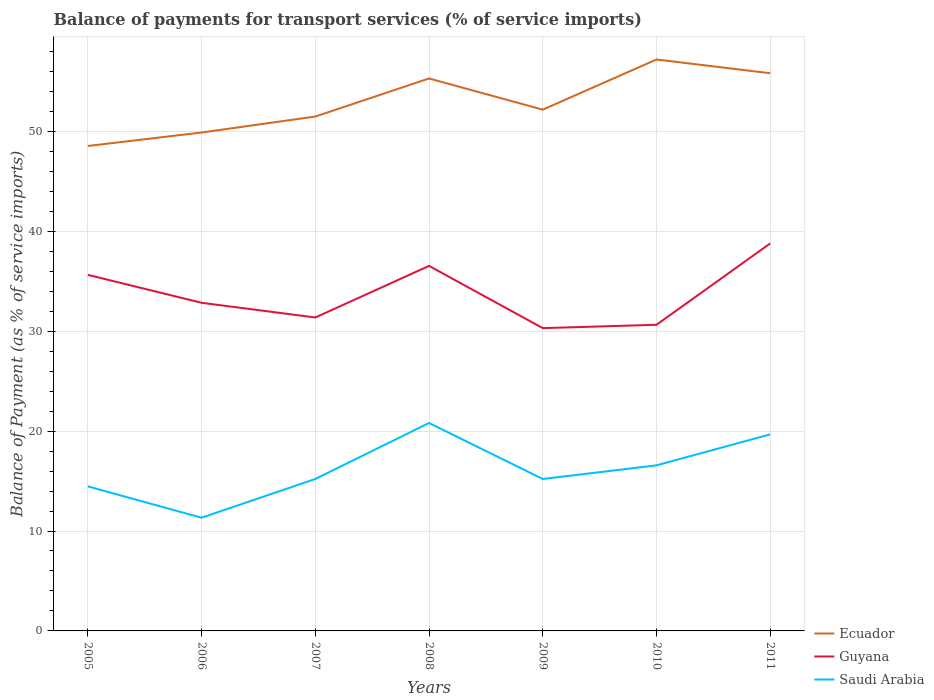How many different coloured lines are there?
Provide a short and direct response. 3. Does the line corresponding to Guyana intersect with the line corresponding to Saudi Arabia?
Your answer should be very brief. No. Is the number of lines equal to the number of legend labels?
Offer a terse response. Yes. Across all years, what is the maximum balance of payments for transport services in Ecuador?
Provide a short and direct response. 48.53. What is the total balance of payments for transport services in Ecuador in the graph?
Your response must be concise. -3.81. What is the difference between the highest and the second highest balance of payments for transport services in Saudi Arabia?
Your response must be concise. 9.48. What is the difference between the highest and the lowest balance of payments for transport services in Guyana?
Your answer should be compact. 3. How many years are there in the graph?
Offer a very short reply. 7. Are the values on the major ticks of Y-axis written in scientific E-notation?
Ensure brevity in your answer.  No. Does the graph contain any zero values?
Make the answer very short. No. Does the graph contain grids?
Ensure brevity in your answer.  Yes. Where does the legend appear in the graph?
Make the answer very short. Bottom right. How many legend labels are there?
Your answer should be very brief. 3. How are the legend labels stacked?
Make the answer very short. Vertical. What is the title of the graph?
Give a very brief answer. Balance of payments for transport services (% of service imports). What is the label or title of the X-axis?
Ensure brevity in your answer.  Years. What is the label or title of the Y-axis?
Provide a succinct answer. Balance of Payment (as % of service imports). What is the Balance of Payment (as % of service imports) of Ecuador in 2005?
Ensure brevity in your answer.  48.53. What is the Balance of Payment (as % of service imports) in Guyana in 2005?
Ensure brevity in your answer.  35.64. What is the Balance of Payment (as % of service imports) of Saudi Arabia in 2005?
Keep it short and to the point. 14.47. What is the Balance of Payment (as % of service imports) in Ecuador in 2006?
Provide a succinct answer. 49.88. What is the Balance of Payment (as % of service imports) of Guyana in 2006?
Offer a terse response. 32.84. What is the Balance of Payment (as % of service imports) in Saudi Arabia in 2006?
Provide a short and direct response. 11.33. What is the Balance of Payment (as % of service imports) of Ecuador in 2007?
Provide a succinct answer. 51.48. What is the Balance of Payment (as % of service imports) in Guyana in 2007?
Your answer should be very brief. 31.37. What is the Balance of Payment (as % of service imports) of Saudi Arabia in 2007?
Your answer should be compact. 15.21. What is the Balance of Payment (as % of service imports) in Ecuador in 2008?
Offer a very short reply. 55.29. What is the Balance of Payment (as % of service imports) of Guyana in 2008?
Your answer should be very brief. 36.53. What is the Balance of Payment (as % of service imports) of Saudi Arabia in 2008?
Give a very brief answer. 20.81. What is the Balance of Payment (as % of service imports) in Ecuador in 2009?
Provide a succinct answer. 52.17. What is the Balance of Payment (as % of service imports) in Guyana in 2009?
Make the answer very short. 30.31. What is the Balance of Payment (as % of service imports) in Saudi Arabia in 2009?
Ensure brevity in your answer.  15.21. What is the Balance of Payment (as % of service imports) in Ecuador in 2010?
Provide a short and direct response. 57.19. What is the Balance of Payment (as % of service imports) of Guyana in 2010?
Your answer should be very brief. 30.64. What is the Balance of Payment (as % of service imports) in Saudi Arabia in 2010?
Provide a short and direct response. 16.57. What is the Balance of Payment (as % of service imports) of Ecuador in 2011?
Your answer should be compact. 55.82. What is the Balance of Payment (as % of service imports) of Guyana in 2011?
Your answer should be compact. 38.79. What is the Balance of Payment (as % of service imports) of Saudi Arabia in 2011?
Offer a terse response. 19.67. Across all years, what is the maximum Balance of Payment (as % of service imports) in Ecuador?
Provide a short and direct response. 57.19. Across all years, what is the maximum Balance of Payment (as % of service imports) in Guyana?
Offer a terse response. 38.79. Across all years, what is the maximum Balance of Payment (as % of service imports) in Saudi Arabia?
Offer a very short reply. 20.81. Across all years, what is the minimum Balance of Payment (as % of service imports) in Ecuador?
Your answer should be very brief. 48.53. Across all years, what is the minimum Balance of Payment (as % of service imports) of Guyana?
Provide a short and direct response. 30.31. Across all years, what is the minimum Balance of Payment (as % of service imports) of Saudi Arabia?
Provide a succinct answer. 11.33. What is the total Balance of Payment (as % of service imports) of Ecuador in the graph?
Ensure brevity in your answer.  370.38. What is the total Balance of Payment (as % of service imports) in Guyana in the graph?
Your answer should be compact. 236.12. What is the total Balance of Payment (as % of service imports) of Saudi Arabia in the graph?
Make the answer very short. 113.27. What is the difference between the Balance of Payment (as % of service imports) in Ecuador in 2005 and that in 2006?
Keep it short and to the point. -1.35. What is the difference between the Balance of Payment (as % of service imports) of Guyana in 2005 and that in 2006?
Provide a short and direct response. 2.8. What is the difference between the Balance of Payment (as % of service imports) in Saudi Arabia in 2005 and that in 2006?
Give a very brief answer. 3.14. What is the difference between the Balance of Payment (as % of service imports) of Ecuador in 2005 and that in 2007?
Provide a succinct answer. -2.95. What is the difference between the Balance of Payment (as % of service imports) in Guyana in 2005 and that in 2007?
Your response must be concise. 4.27. What is the difference between the Balance of Payment (as % of service imports) in Saudi Arabia in 2005 and that in 2007?
Make the answer very short. -0.74. What is the difference between the Balance of Payment (as % of service imports) of Ecuador in 2005 and that in 2008?
Ensure brevity in your answer.  -6.76. What is the difference between the Balance of Payment (as % of service imports) of Guyana in 2005 and that in 2008?
Your response must be concise. -0.9. What is the difference between the Balance of Payment (as % of service imports) in Saudi Arabia in 2005 and that in 2008?
Ensure brevity in your answer.  -6.34. What is the difference between the Balance of Payment (as % of service imports) of Ecuador in 2005 and that in 2009?
Ensure brevity in your answer.  -3.64. What is the difference between the Balance of Payment (as % of service imports) in Guyana in 2005 and that in 2009?
Ensure brevity in your answer.  5.33. What is the difference between the Balance of Payment (as % of service imports) in Saudi Arabia in 2005 and that in 2009?
Offer a terse response. -0.74. What is the difference between the Balance of Payment (as % of service imports) in Ecuador in 2005 and that in 2010?
Keep it short and to the point. -8.66. What is the difference between the Balance of Payment (as % of service imports) in Guyana in 2005 and that in 2010?
Your answer should be compact. 5. What is the difference between the Balance of Payment (as % of service imports) in Saudi Arabia in 2005 and that in 2010?
Provide a short and direct response. -2.11. What is the difference between the Balance of Payment (as % of service imports) of Ecuador in 2005 and that in 2011?
Ensure brevity in your answer.  -7.28. What is the difference between the Balance of Payment (as % of service imports) of Guyana in 2005 and that in 2011?
Ensure brevity in your answer.  -3.15. What is the difference between the Balance of Payment (as % of service imports) of Saudi Arabia in 2005 and that in 2011?
Your response must be concise. -5.2. What is the difference between the Balance of Payment (as % of service imports) of Ecuador in 2006 and that in 2007?
Ensure brevity in your answer.  -1.6. What is the difference between the Balance of Payment (as % of service imports) of Guyana in 2006 and that in 2007?
Your answer should be very brief. 1.47. What is the difference between the Balance of Payment (as % of service imports) in Saudi Arabia in 2006 and that in 2007?
Keep it short and to the point. -3.88. What is the difference between the Balance of Payment (as % of service imports) of Ecuador in 2006 and that in 2008?
Your answer should be very brief. -5.41. What is the difference between the Balance of Payment (as % of service imports) in Guyana in 2006 and that in 2008?
Offer a terse response. -3.69. What is the difference between the Balance of Payment (as % of service imports) in Saudi Arabia in 2006 and that in 2008?
Ensure brevity in your answer.  -9.48. What is the difference between the Balance of Payment (as % of service imports) of Ecuador in 2006 and that in 2009?
Keep it short and to the point. -2.29. What is the difference between the Balance of Payment (as % of service imports) in Guyana in 2006 and that in 2009?
Your response must be concise. 2.54. What is the difference between the Balance of Payment (as % of service imports) of Saudi Arabia in 2006 and that in 2009?
Offer a very short reply. -3.88. What is the difference between the Balance of Payment (as % of service imports) in Ecuador in 2006 and that in 2010?
Provide a succinct answer. -7.31. What is the difference between the Balance of Payment (as % of service imports) of Guyana in 2006 and that in 2010?
Your answer should be very brief. 2.2. What is the difference between the Balance of Payment (as % of service imports) of Saudi Arabia in 2006 and that in 2010?
Give a very brief answer. -5.24. What is the difference between the Balance of Payment (as % of service imports) in Ecuador in 2006 and that in 2011?
Keep it short and to the point. -5.93. What is the difference between the Balance of Payment (as % of service imports) in Guyana in 2006 and that in 2011?
Offer a very short reply. -5.95. What is the difference between the Balance of Payment (as % of service imports) of Saudi Arabia in 2006 and that in 2011?
Offer a very short reply. -8.34. What is the difference between the Balance of Payment (as % of service imports) in Ecuador in 2007 and that in 2008?
Provide a short and direct response. -3.81. What is the difference between the Balance of Payment (as % of service imports) of Guyana in 2007 and that in 2008?
Provide a short and direct response. -5.16. What is the difference between the Balance of Payment (as % of service imports) in Saudi Arabia in 2007 and that in 2008?
Your answer should be compact. -5.6. What is the difference between the Balance of Payment (as % of service imports) of Ecuador in 2007 and that in 2009?
Your response must be concise. -0.69. What is the difference between the Balance of Payment (as % of service imports) in Guyana in 2007 and that in 2009?
Your response must be concise. 1.07. What is the difference between the Balance of Payment (as % of service imports) in Saudi Arabia in 2007 and that in 2009?
Your response must be concise. 0. What is the difference between the Balance of Payment (as % of service imports) of Ecuador in 2007 and that in 2010?
Keep it short and to the point. -5.71. What is the difference between the Balance of Payment (as % of service imports) in Guyana in 2007 and that in 2010?
Your response must be concise. 0.73. What is the difference between the Balance of Payment (as % of service imports) of Saudi Arabia in 2007 and that in 2010?
Your response must be concise. -1.37. What is the difference between the Balance of Payment (as % of service imports) in Ecuador in 2007 and that in 2011?
Provide a short and direct response. -4.33. What is the difference between the Balance of Payment (as % of service imports) in Guyana in 2007 and that in 2011?
Offer a terse response. -7.42. What is the difference between the Balance of Payment (as % of service imports) in Saudi Arabia in 2007 and that in 2011?
Provide a short and direct response. -4.46. What is the difference between the Balance of Payment (as % of service imports) in Ecuador in 2008 and that in 2009?
Your answer should be very brief. 3.12. What is the difference between the Balance of Payment (as % of service imports) in Guyana in 2008 and that in 2009?
Offer a terse response. 6.23. What is the difference between the Balance of Payment (as % of service imports) in Saudi Arabia in 2008 and that in 2009?
Provide a short and direct response. 5.6. What is the difference between the Balance of Payment (as % of service imports) in Ecuador in 2008 and that in 2010?
Your answer should be compact. -1.9. What is the difference between the Balance of Payment (as % of service imports) of Guyana in 2008 and that in 2010?
Offer a terse response. 5.89. What is the difference between the Balance of Payment (as % of service imports) of Saudi Arabia in 2008 and that in 2010?
Your response must be concise. 4.24. What is the difference between the Balance of Payment (as % of service imports) in Ecuador in 2008 and that in 2011?
Provide a succinct answer. -0.52. What is the difference between the Balance of Payment (as % of service imports) in Guyana in 2008 and that in 2011?
Keep it short and to the point. -2.25. What is the difference between the Balance of Payment (as % of service imports) in Saudi Arabia in 2008 and that in 2011?
Ensure brevity in your answer.  1.14. What is the difference between the Balance of Payment (as % of service imports) in Ecuador in 2009 and that in 2010?
Your answer should be very brief. -5.02. What is the difference between the Balance of Payment (as % of service imports) of Guyana in 2009 and that in 2010?
Provide a succinct answer. -0.33. What is the difference between the Balance of Payment (as % of service imports) in Saudi Arabia in 2009 and that in 2010?
Your response must be concise. -1.37. What is the difference between the Balance of Payment (as % of service imports) of Ecuador in 2009 and that in 2011?
Your response must be concise. -3.64. What is the difference between the Balance of Payment (as % of service imports) in Guyana in 2009 and that in 2011?
Make the answer very short. -8.48. What is the difference between the Balance of Payment (as % of service imports) in Saudi Arabia in 2009 and that in 2011?
Make the answer very short. -4.47. What is the difference between the Balance of Payment (as % of service imports) of Ecuador in 2010 and that in 2011?
Provide a succinct answer. 1.38. What is the difference between the Balance of Payment (as % of service imports) of Guyana in 2010 and that in 2011?
Keep it short and to the point. -8.15. What is the difference between the Balance of Payment (as % of service imports) in Saudi Arabia in 2010 and that in 2011?
Give a very brief answer. -3.1. What is the difference between the Balance of Payment (as % of service imports) in Ecuador in 2005 and the Balance of Payment (as % of service imports) in Guyana in 2006?
Give a very brief answer. 15.69. What is the difference between the Balance of Payment (as % of service imports) of Ecuador in 2005 and the Balance of Payment (as % of service imports) of Saudi Arabia in 2006?
Provide a short and direct response. 37.21. What is the difference between the Balance of Payment (as % of service imports) of Guyana in 2005 and the Balance of Payment (as % of service imports) of Saudi Arabia in 2006?
Your response must be concise. 24.31. What is the difference between the Balance of Payment (as % of service imports) in Ecuador in 2005 and the Balance of Payment (as % of service imports) in Guyana in 2007?
Ensure brevity in your answer.  17.16. What is the difference between the Balance of Payment (as % of service imports) of Ecuador in 2005 and the Balance of Payment (as % of service imports) of Saudi Arabia in 2007?
Offer a very short reply. 33.33. What is the difference between the Balance of Payment (as % of service imports) in Guyana in 2005 and the Balance of Payment (as % of service imports) in Saudi Arabia in 2007?
Your response must be concise. 20.43. What is the difference between the Balance of Payment (as % of service imports) of Ecuador in 2005 and the Balance of Payment (as % of service imports) of Guyana in 2008?
Your answer should be very brief. 12. What is the difference between the Balance of Payment (as % of service imports) in Ecuador in 2005 and the Balance of Payment (as % of service imports) in Saudi Arabia in 2008?
Provide a succinct answer. 27.72. What is the difference between the Balance of Payment (as % of service imports) of Guyana in 2005 and the Balance of Payment (as % of service imports) of Saudi Arabia in 2008?
Make the answer very short. 14.83. What is the difference between the Balance of Payment (as % of service imports) in Ecuador in 2005 and the Balance of Payment (as % of service imports) in Guyana in 2009?
Your response must be concise. 18.23. What is the difference between the Balance of Payment (as % of service imports) of Ecuador in 2005 and the Balance of Payment (as % of service imports) of Saudi Arabia in 2009?
Ensure brevity in your answer.  33.33. What is the difference between the Balance of Payment (as % of service imports) in Guyana in 2005 and the Balance of Payment (as % of service imports) in Saudi Arabia in 2009?
Give a very brief answer. 20.43. What is the difference between the Balance of Payment (as % of service imports) in Ecuador in 2005 and the Balance of Payment (as % of service imports) in Guyana in 2010?
Keep it short and to the point. 17.89. What is the difference between the Balance of Payment (as % of service imports) of Ecuador in 2005 and the Balance of Payment (as % of service imports) of Saudi Arabia in 2010?
Offer a very short reply. 31.96. What is the difference between the Balance of Payment (as % of service imports) in Guyana in 2005 and the Balance of Payment (as % of service imports) in Saudi Arabia in 2010?
Offer a very short reply. 19.06. What is the difference between the Balance of Payment (as % of service imports) in Ecuador in 2005 and the Balance of Payment (as % of service imports) in Guyana in 2011?
Give a very brief answer. 9.75. What is the difference between the Balance of Payment (as % of service imports) of Ecuador in 2005 and the Balance of Payment (as % of service imports) of Saudi Arabia in 2011?
Offer a terse response. 28.86. What is the difference between the Balance of Payment (as % of service imports) of Guyana in 2005 and the Balance of Payment (as % of service imports) of Saudi Arabia in 2011?
Provide a succinct answer. 15.97. What is the difference between the Balance of Payment (as % of service imports) in Ecuador in 2006 and the Balance of Payment (as % of service imports) in Guyana in 2007?
Make the answer very short. 18.51. What is the difference between the Balance of Payment (as % of service imports) of Ecuador in 2006 and the Balance of Payment (as % of service imports) of Saudi Arabia in 2007?
Offer a terse response. 34.68. What is the difference between the Balance of Payment (as % of service imports) in Guyana in 2006 and the Balance of Payment (as % of service imports) in Saudi Arabia in 2007?
Offer a very short reply. 17.63. What is the difference between the Balance of Payment (as % of service imports) of Ecuador in 2006 and the Balance of Payment (as % of service imports) of Guyana in 2008?
Your response must be concise. 13.35. What is the difference between the Balance of Payment (as % of service imports) in Ecuador in 2006 and the Balance of Payment (as % of service imports) in Saudi Arabia in 2008?
Offer a terse response. 29.07. What is the difference between the Balance of Payment (as % of service imports) of Guyana in 2006 and the Balance of Payment (as % of service imports) of Saudi Arabia in 2008?
Ensure brevity in your answer.  12.03. What is the difference between the Balance of Payment (as % of service imports) in Ecuador in 2006 and the Balance of Payment (as % of service imports) in Guyana in 2009?
Provide a short and direct response. 19.58. What is the difference between the Balance of Payment (as % of service imports) in Ecuador in 2006 and the Balance of Payment (as % of service imports) in Saudi Arabia in 2009?
Ensure brevity in your answer.  34.68. What is the difference between the Balance of Payment (as % of service imports) in Guyana in 2006 and the Balance of Payment (as % of service imports) in Saudi Arabia in 2009?
Give a very brief answer. 17.64. What is the difference between the Balance of Payment (as % of service imports) in Ecuador in 2006 and the Balance of Payment (as % of service imports) in Guyana in 2010?
Your answer should be compact. 19.24. What is the difference between the Balance of Payment (as % of service imports) in Ecuador in 2006 and the Balance of Payment (as % of service imports) in Saudi Arabia in 2010?
Your answer should be very brief. 33.31. What is the difference between the Balance of Payment (as % of service imports) in Guyana in 2006 and the Balance of Payment (as % of service imports) in Saudi Arabia in 2010?
Offer a terse response. 16.27. What is the difference between the Balance of Payment (as % of service imports) in Ecuador in 2006 and the Balance of Payment (as % of service imports) in Guyana in 2011?
Ensure brevity in your answer.  11.1. What is the difference between the Balance of Payment (as % of service imports) of Ecuador in 2006 and the Balance of Payment (as % of service imports) of Saudi Arabia in 2011?
Ensure brevity in your answer.  30.21. What is the difference between the Balance of Payment (as % of service imports) in Guyana in 2006 and the Balance of Payment (as % of service imports) in Saudi Arabia in 2011?
Offer a very short reply. 13.17. What is the difference between the Balance of Payment (as % of service imports) in Ecuador in 2007 and the Balance of Payment (as % of service imports) in Guyana in 2008?
Your answer should be very brief. 14.95. What is the difference between the Balance of Payment (as % of service imports) of Ecuador in 2007 and the Balance of Payment (as % of service imports) of Saudi Arabia in 2008?
Provide a short and direct response. 30.67. What is the difference between the Balance of Payment (as % of service imports) of Guyana in 2007 and the Balance of Payment (as % of service imports) of Saudi Arabia in 2008?
Your response must be concise. 10.56. What is the difference between the Balance of Payment (as % of service imports) in Ecuador in 2007 and the Balance of Payment (as % of service imports) in Guyana in 2009?
Give a very brief answer. 21.18. What is the difference between the Balance of Payment (as % of service imports) of Ecuador in 2007 and the Balance of Payment (as % of service imports) of Saudi Arabia in 2009?
Give a very brief answer. 36.28. What is the difference between the Balance of Payment (as % of service imports) of Guyana in 2007 and the Balance of Payment (as % of service imports) of Saudi Arabia in 2009?
Offer a terse response. 16.17. What is the difference between the Balance of Payment (as % of service imports) of Ecuador in 2007 and the Balance of Payment (as % of service imports) of Guyana in 2010?
Give a very brief answer. 20.84. What is the difference between the Balance of Payment (as % of service imports) in Ecuador in 2007 and the Balance of Payment (as % of service imports) in Saudi Arabia in 2010?
Give a very brief answer. 34.91. What is the difference between the Balance of Payment (as % of service imports) of Guyana in 2007 and the Balance of Payment (as % of service imports) of Saudi Arabia in 2010?
Provide a short and direct response. 14.8. What is the difference between the Balance of Payment (as % of service imports) in Ecuador in 2007 and the Balance of Payment (as % of service imports) in Guyana in 2011?
Offer a very short reply. 12.7. What is the difference between the Balance of Payment (as % of service imports) in Ecuador in 2007 and the Balance of Payment (as % of service imports) in Saudi Arabia in 2011?
Your answer should be very brief. 31.81. What is the difference between the Balance of Payment (as % of service imports) in Guyana in 2007 and the Balance of Payment (as % of service imports) in Saudi Arabia in 2011?
Provide a short and direct response. 11.7. What is the difference between the Balance of Payment (as % of service imports) of Ecuador in 2008 and the Balance of Payment (as % of service imports) of Guyana in 2009?
Provide a short and direct response. 24.99. What is the difference between the Balance of Payment (as % of service imports) of Ecuador in 2008 and the Balance of Payment (as % of service imports) of Saudi Arabia in 2009?
Give a very brief answer. 40.09. What is the difference between the Balance of Payment (as % of service imports) of Guyana in 2008 and the Balance of Payment (as % of service imports) of Saudi Arabia in 2009?
Give a very brief answer. 21.33. What is the difference between the Balance of Payment (as % of service imports) in Ecuador in 2008 and the Balance of Payment (as % of service imports) in Guyana in 2010?
Provide a succinct answer. 24.65. What is the difference between the Balance of Payment (as % of service imports) of Ecuador in 2008 and the Balance of Payment (as % of service imports) of Saudi Arabia in 2010?
Keep it short and to the point. 38.72. What is the difference between the Balance of Payment (as % of service imports) of Guyana in 2008 and the Balance of Payment (as % of service imports) of Saudi Arabia in 2010?
Your answer should be compact. 19.96. What is the difference between the Balance of Payment (as % of service imports) in Ecuador in 2008 and the Balance of Payment (as % of service imports) in Guyana in 2011?
Provide a succinct answer. 16.51. What is the difference between the Balance of Payment (as % of service imports) of Ecuador in 2008 and the Balance of Payment (as % of service imports) of Saudi Arabia in 2011?
Your answer should be very brief. 35.62. What is the difference between the Balance of Payment (as % of service imports) of Guyana in 2008 and the Balance of Payment (as % of service imports) of Saudi Arabia in 2011?
Offer a very short reply. 16.86. What is the difference between the Balance of Payment (as % of service imports) of Ecuador in 2009 and the Balance of Payment (as % of service imports) of Guyana in 2010?
Ensure brevity in your answer.  21.53. What is the difference between the Balance of Payment (as % of service imports) in Ecuador in 2009 and the Balance of Payment (as % of service imports) in Saudi Arabia in 2010?
Your answer should be very brief. 35.6. What is the difference between the Balance of Payment (as % of service imports) of Guyana in 2009 and the Balance of Payment (as % of service imports) of Saudi Arabia in 2010?
Ensure brevity in your answer.  13.73. What is the difference between the Balance of Payment (as % of service imports) of Ecuador in 2009 and the Balance of Payment (as % of service imports) of Guyana in 2011?
Your answer should be very brief. 13.38. What is the difference between the Balance of Payment (as % of service imports) in Ecuador in 2009 and the Balance of Payment (as % of service imports) in Saudi Arabia in 2011?
Offer a very short reply. 32.5. What is the difference between the Balance of Payment (as % of service imports) of Guyana in 2009 and the Balance of Payment (as % of service imports) of Saudi Arabia in 2011?
Keep it short and to the point. 10.63. What is the difference between the Balance of Payment (as % of service imports) in Ecuador in 2010 and the Balance of Payment (as % of service imports) in Guyana in 2011?
Offer a very short reply. 18.41. What is the difference between the Balance of Payment (as % of service imports) of Ecuador in 2010 and the Balance of Payment (as % of service imports) of Saudi Arabia in 2011?
Offer a terse response. 37.52. What is the difference between the Balance of Payment (as % of service imports) in Guyana in 2010 and the Balance of Payment (as % of service imports) in Saudi Arabia in 2011?
Keep it short and to the point. 10.97. What is the average Balance of Payment (as % of service imports) of Ecuador per year?
Your response must be concise. 52.91. What is the average Balance of Payment (as % of service imports) in Guyana per year?
Your answer should be compact. 33.73. What is the average Balance of Payment (as % of service imports) in Saudi Arabia per year?
Make the answer very short. 16.18. In the year 2005, what is the difference between the Balance of Payment (as % of service imports) of Ecuador and Balance of Payment (as % of service imports) of Guyana?
Ensure brevity in your answer.  12.9. In the year 2005, what is the difference between the Balance of Payment (as % of service imports) in Ecuador and Balance of Payment (as % of service imports) in Saudi Arabia?
Make the answer very short. 34.07. In the year 2005, what is the difference between the Balance of Payment (as % of service imports) of Guyana and Balance of Payment (as % of service imports) of Saudi Arabia?
Your answer should be compact. 21.17. In the year 2006, what is the difference between the Balance of Payment (as % of service imports) of Ecuador and Balance of Payment (as % of service imports) of Guyana?
Give a very brief answer. 17.04. In the year 2006, what is the difference between the Balance of Payment (as % of service imports) of Ecuador and Balance of Payment (as % of service imports) of Saudi Arabia?
Make the answer very short. 38.55. In the year 2006, what is the difference between the Balance of Payment (as % of service imports) of Guyana and Balance of Payment (as % of service imports) of Saudi Arabia?
Keep it short and to the point. 21.51. In the year 2007, what is the difference between the Balance of Payment (as % of service imports) in Ecuador and Balance of Payment (as % of service imports) in Guyana?
Ensure brevity in your answer.  20.11. In the year 2007, what is the difference between the Balance of Payment (as % of service imports) in Ecuador and Balance of Payment (as % of service imports) in Saudi Arabia?
Keep it short and to the point. 36.27. In the year 2007, what is the difference between the Balance of Payment (as % of service imports) in Guyana and Balance of Payment (as % of service imports) in Saudi Arabia?
Ensure brevity in your answer.  16.16. In the year 2008, what is the difference between the Balance of Payment (as % of service imports) in Ecuador and Balance of Payment (as % of service imports) in Guyana?
Your answer should be very brief. 18.76. In the year 2008, what is the difference between the Balance of Payment (as % of service imports) of Ecuador and Balance of Payment (as % of service imports) of Saudi Arabia?
Give a very brief answer. 34.48. In the year 2008, what is the difference between the Balance of Payment (as % of service imports) in Guyana and Balance of Payment (as % of service imports) in Saudi Arabia?
Provide a succinct answer. 15.72. In the year 2009, what is the difference between the Balance of Payment (as % of service imports) in Ecuador and Balance of Payment (as % of service imports) in Guyana?
Ensure brevity in your answer.  21.87. In the year 2009, what is the difference between the Balance of Payment (as % of service imports) in Ecuador and Balance of Payment (as % of service imports) in Saudi Arabia?
Your answer should be compact. 36.97. In the year 2010, what is the difference between the Balance of Payment (as % of service imports) in Ecuador and Balance of Payment (as % of service imports) in Guyana?
Offer a very short reply. 26.55. In the year 2010, what is the difference between the Balance of Payment (as % of service imports) in Ecuador and Balance of Payment (as % of service imports) in Saudi Arabia?
Offer a very short reply. 40.62. In the year 2010, what is the difference between the Balance of Payment (as % of service imports) of Guyana and Balance of Payment (as % of service imports) of Saudi Arabia?
Provide a succinct answer. 14.07. In the year 2011, what is the difference between the Balance of Payment (as % of service imports) of Ecuador and Balance of Payment (as % of service imports) of Guyana?
Keep it short and to the point. 17.03. In the year 2011, what is the difference between the Balance of Payment (as % of service imports) of Ecuador and Balance of Payment (as % of service imports) of Saudi Arabia?
Your answer should be compact. 36.14. In the year 2011, what is the difference between the Balance of Payment (as % of service imports) of Guyana and Balance of Payment (as % of service imports) of Saudi Arabia?
Provide a short and direct response. 19.12. What is the ratio of the Balance of Payment (as % of service imports) in Ecuador in 2005 to that in 2006?
Ensure brevity in your answer.  0.97. What is the ratio of the Balance of Payment (as % of service imports) in Guyana in 2005 to that in 2006?
Offer a terse response. 1.09. What is the ratio of the Balance of Payment (as % of service imports) in Saudi Arabia in 2005 to that in 2006?
Provide a short and direct response. 1.28. What is the ratio of the Balance of Payment (as % of service imports) in Ecuador in 2005 to that in 2007?
Ensure brevity in your answer.  0.94. What is the ratio of the Balance of Payment (as % of service imports) of Guyana in 2005 to that in 2007?
Provide a succinct answer. 1.14. What is the ratio of the Balance of Payment (as % of service imports) in Saudi Arabia in 2005 to that in 2007?
Your answer should be very brief. 0.95. What is the ratio of the Balance of Payment (as % of service imports) of Ecuador in 2005 to that in 2008?
Provide a short and direct response. 0.88. What is the ratio of the Balance of Payment (as % of service imports) in Guyana in 2005 to that in 2008?
Give a very brief answer. 0.98. What is the ratio of the Balance of Payment (as % of service imports) in Saudi Arabia in 2005 to that in 2008?
Offer a very short reply. 0.7. What is the ratio of the Balance of Payment (as % of service imports) of Ecuador in 2005 to that in 2009?
Offer a terse response. 0.93. What is the ratio of the Balance of Payment (as % of service imports) of Guyana in 2005 to that in 2009?
Provide a short and direct response. 1.18. What is the ratio of the Balance of Payment (as % of service imports) in Saudi Arabia in 2005 to that in 2009?
Offer a very short reply. 0.95. What is the ratio of the Balance of Payment (as % of service imports) of Ecuador in 2005 to that in 2010?
Provide a short and direct response. 0.85. What is the ratio of the Balance of Payment (as % of service imports) of Guyana in 2005 to that in 2010?
Offer a terse response. 1.16. What is the ratio of the Balance of Payment (as % of service imports) of Saudi Arabia in 2005 to that in 2010?
Offer a terse response. 0.87. What is the ratio of the Balance of Payment (as % of service imports) in Ecuador in 2005 to that in 2011?
Make the answer very short. 0.87. What is the ratio of the Balance of Payment (as % of service imports) in Guyana in 2005 to that in 2011?
Your response must be concise. 0.92. What is the ratio of the Balance of Payment (as % of service imports) in Saudi Arabia in 2005 to that in 2011?
Provide a short and direct response. 0.74. What is the ratio of the Balance of Payment (as % of service imports) in Ecuador in 2006 to that in 2007?
Provide a succinct answer. 0.97. What is the ratio of the Balance of Payment (as % of service imports) of Guyana in 2006 to that in 2007?
Your answer should be compact. 1.05. What is the ratio of the Balance of Payment (as % of service imports) of Saudi Arabia in 2006 to that in 2007?
Provide a short and direct response. 0.74. What is the ratio of the Balance of Payment (as % of service imports) of Ecuador in 2006 to that in 2008?
Give a very brief answer. 0.9. What is the ratio of the Balance of Payment (as % of service imports) in Guyana in 2006 to that in 2008?
Your response must be concise. 0.9. What is the ratio of the Balance of Payment (as % of service imports) of Saudi Arabia in 2006 to that in 2008?
Offer a terse response. 0.54. What is the ratio of the Balance of Payment (as % of service imports) in Ecuador in 2006 to that in 2009?
Your answer should be very brief. 0.96. What is the ratio of the Balance of Payment (as % of service imports) in Guyana in 2006 to that in 2009?
Ensure brevity in your answer.  1.08. What is the ratio of the Balance of Payment (as % of service imports) in Saudi Arabia in 2006 to that in 2009?
Make the answer very short. 0.75. What is the ratio of the Balance of Payment (as % of service imports) of Ecuador in 2006 to that in 2010?
Offer a terse response. 0.87. What is the ratio of the Balance of Payment (as % of service imports) of Guyana in 2006 to that in 2010?
Offer a terse response. 1.07. What is the ratio of the Balance of Payment (as % of service imports) of Saudi Arabia in 2006 to that in 2010?
Keep it short and to the point. 0.68. What is the ratio of the Balance of Payment (as % of service imports) of Ecuador in 2006 to that in 2011?
Your answer should be very brief. 0.89. What is the ratio of the Balance of Payment (as % of service imports) of Guyana in 2006 to that in 2011?
Provide a succinct answer. 0.85. What is the ratio of the Balance of Payment (as % of service imports) of Saudi Arabia in 2006 to that in 2011?
Your answer should be very brief. 0.58. What is the ratio of the Balance of Payment (as % of service imports) in Ecuador in 2007 to that in 2008?
Provide a succinct answer. 0.93. What is the ratio of the Balance of Payment (as % of service imports) in Guyana in 2007 to that in 2008?
Your response must be concise. 0.86. What is the ratio of the Balance of Payment (as % of service imports) in Saudi Arabia in 2007 to that in 2008?
Your response must be concise. 0.73. What is the ratio of the Balance of Payment (as % of service imports) of Guyana in 2007 to that in 2009?
Your answer should be very brief. 1.04. What is the ratio of the Balance of Payment (as % of service imports) of Ecuador in 2007 to that in 2010?
Make the answer very short. 0.9. What is the ratio of the Balance of Payment (as % of service imports) in Guyana in 2007 to that in 2010?
Ensure brevity in your answer.  1.02. What is the ratio of the Balance of Payment (as % of service imports) in Saudi Arabia in 2007 to that in 2010?
Ensure brevity in your answer.  0.92. What is the ratio of the Balance of Payment (as % of service imports) of Ecuador in 2007 to that in 2011?
Provide a short and direct response. 0.92. What is the ratio of the Balance of Payment (as % of service imports) of Guyana in 2007 to that in 2011?
Your answer should be compact. 0.81. What is the ratio of the Balance of Payment (as % of service imports) of Saudi Arabia in 2007 to that in 2011?
Your answer should be very brief. 0.77. What is the ratio of the Balance of Payment (as % of service imports) in Ecuador in 2008 to that in 2009?
Make the answer very short. 1.06. What is the ratio of the Balance of Payment (as % of service imports) in Guyana in 2008 to that in 2009?
Offer a very short reply. 1.21. What is the ratio of the Balance of Payment (as % of service imports) of Saudi Arabia in 2008 to that in 2009?
Ensure brevity in your answer.  1.37. What is the ratio of the Balance of Payment (as % of service imports) of Ecuador in 2008 to that in 2010?
Make the answer very short. 0.97. What is the ratio of the Balance of Payment (as % of service imports) in Guyana in 2008 to that in 2010?
Your answer should be compact. 1.19. What is the ratio of the Balance of Payment (as % of service imports) of Saudi Arabia in 2008 to that in 2010?
Make the answer very short. 1.26. What is the ratio of the Balance of Payment (as % of service imports) of Ecuador in 2008 to that in 2011?
Offer a very short reply. 0.99. What is the ratio of the Balance of Payment (as % of service imports) of Guyana in 2008 to that in 2011?
Keep it short and to the point. 0.94. What is the ratio of the Balance of Payment (as % of service imports) in Saudi Arabia in 2008 to that in 2011?
Your answer should be very brief. 1.06. What is the ratio of the Balance of Payment (as % of service imports) of Ecuador in 2009 to that in 2010?
Your answer should be very brief. 0.91. What is the ratio of the Balance of Payment (as % of service imports) in Guyana in 2009 to that in 2010?
Give a very brief answer. 0.99. What is the ratio of the Balance of Payment (as % of service imports) of Saudi Arabia in 2009 to that in 2010?
Make the answer very short. 0.92. What is the ratio of the Balance of Payment (as % of service imports) of Ecuador in 2009 to that in 2011?
Provide a short and direct response. 0.93. What is the ratio of the Balance of Payment (as % of service imports) in Guyana in 2009 to that in 2011?
Your answer should be very brief. 0.78. What is the ratio of the Balance of Payment (as % of service imports) in Saudi Arabia in 2009 to that in 2011?
Your answer should be very brief. 0.77. What is the ratio of the Balance of Payment (as % of service imports) in Ecuador in 2010 to that in 2011?
Offer a very short reply. 1.02. What is the ratio of the Balance of Payment (as % of service imports) in Guyana in 2010 to that in 2011?
Your answer should be compact. 0.79. What is the ratio of the Balance of Payment (as % of service imports) in Saudi Arabia in 2010 to that in 2011?
Your answer should be compact. 0.84. What is the difference between the highest and the second highest Balance of Payment (as % of service imports) in Ecuador?
Your answer should be compact. 1.38. What is the difference between the highest and the second highest Balance of Payment (as % of service imports) of Guyana?
Give a very brief answer. 2.25. What is the difference between the highest and the second highest Balance of Payment (as % of service imports) of Saudi Arabia?
Provide a succinct answer. 1.14. What is the difference between the highest and the lowest Balance of Payment (as % of service imports) in Ecuador?
Provide a short and direct response. 8.66. What is the difference between the highest and the lowest Balance of Payment (as % of service imports) in Guyana?
Offer a very short reply. 8.48. What is the difference between the highest and the lowest Balance of Payment (as % of service imports) of Saudi Arabia?
Your answer should be compact. 9.48. 